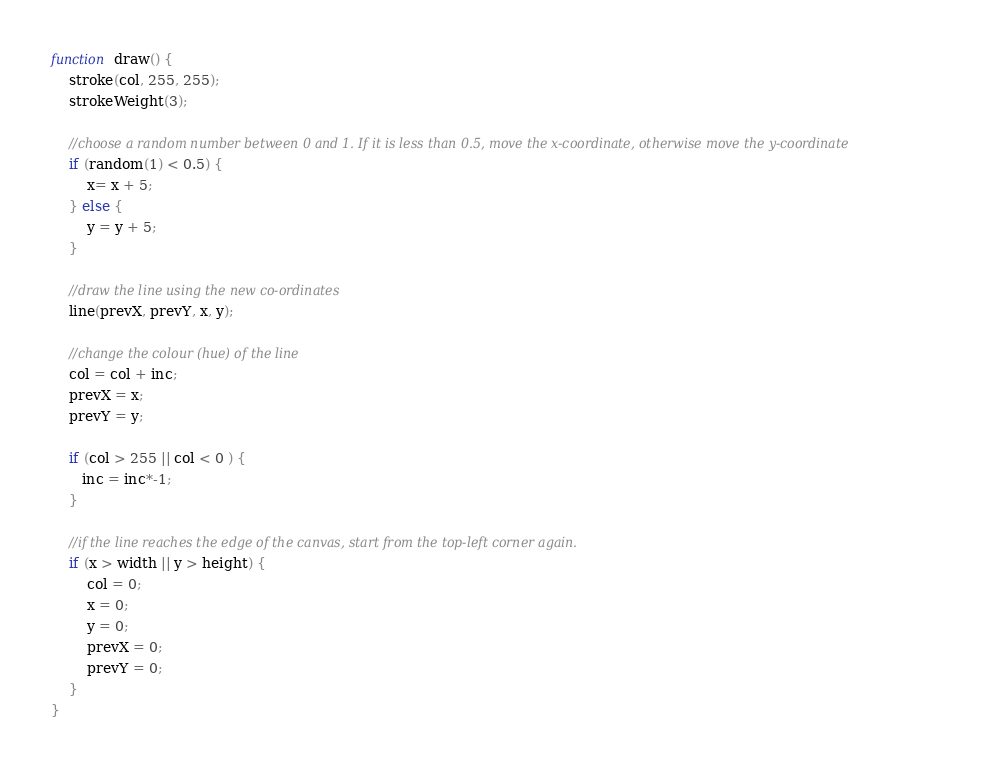Convert code to text. <code><loc_0><loc_0><loc_500><loc_500><_JavaScript_>function draw() {
    stroke(col, 255, 255);
    strokeWeight(3);    

    //choose a random number between 0 and 1. If it is less than 0.5, move the x-coordinate, otherwise move the y-coordinate
    if (random(1) < 0.5) {
        x= x + 5;        
    } else { 
        y = y + 5;
    }
    
    //draw the line using the new co-ordinates
    line(prevX, prevY, x, y); 
    
    //change the colour (hue) of the line
    col = col + inc;
    prevX = x;
    prevY = y;
    
    if (col > 255 || col < 0 ) {
       inc = inc*-1;
    }
    
    //if the line reaches the edge of the canvas, start from the top-left corner again.
    if (x > width || y > height) { 
        col = 0;
        x = 0;
        y = 0;
        prevX = 0;
        prevY = 0;
    }
}</code> 